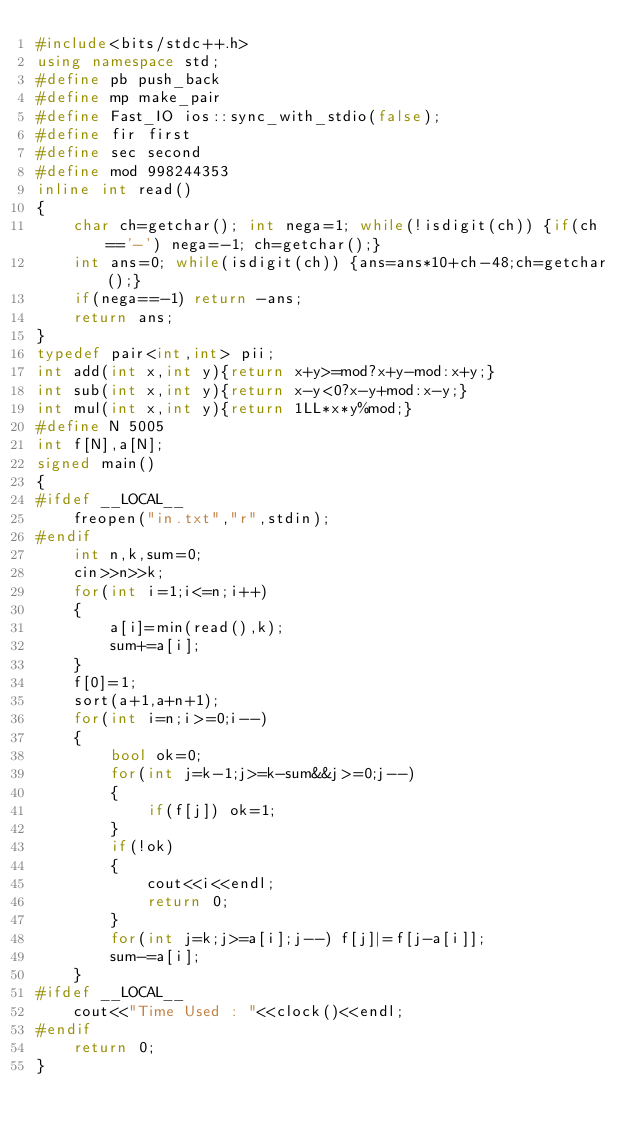Convert code to text. <code><loc_0><loc_0><loc_500><loc_500><_C++_>#include<bits/stdc++.h>
using namespace std;
#define pb push_back
#define mp make_pair
#define Fast_IO ios::sync_with_stdio(false);
#define fir first
#define sec second
#define mod 998244353
inline int read()
{
	char ch=getchar(); int nega=1; while(!isdigit(ch)) {if(ch=='-') nega=-1; ch=getchar();}
	int ans=0; while(isdigit(ch)) {ans=ans*10+ch-48;ch=getchar();}
	if(nega==-1) return -ans;
	return ans;
}
typedef pair<int,int> pii;
int add(int x,int y){return x+y>=mod?x+y-mod:x+y;}
int sub(int x,int y){return x-y<0?x-y+mod:x-y;}
int mul(int x,int y){return 1LL*x*y%mod;}
#define N 5005
int f[N],a[N];
signed main()
{
#ifdef __LOCAL__
	freopen("in.txt","r",stdin);
#endif
	int n,k,sum=0;
	cin>>n>>k;
	for(int i=1;i<=n;i++)
	{
		a[i]=min(read(),k);
		sum+=a[i];
	}
	f[0]=1;
	sort(a+1,a+n+1);
	for(int i=n;i>=0;i--)
	{
		bool ok=0;
		for(int j=k-1;j>=k-sum&&j>=0;j--)
		{
			if(f[j]) ok=1;
		}
		if(!ok)
		{
			cout<<i<<endl;
			return 0;
		}
		for(int j=k;j>=a[i];j--) f[j]|=f[j-a[i]];
		sum-=a[i];
	}
#ifdef __LOCAL__
	cout<<"Time Used : "<<clock()<<endl;
#endif
	return 0;
}

</code> 